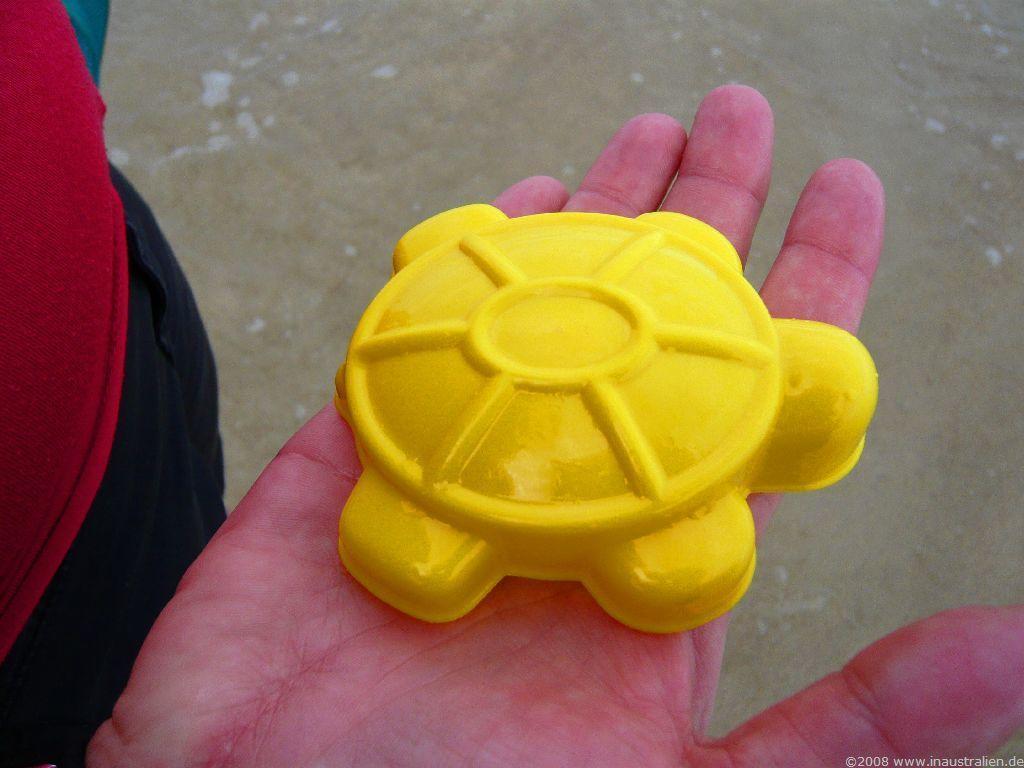Could you give a brief overview of what you see in this image? In this picture, we see the hand of the person holding a yellow color object. On the left side, we see a man wearing the red T-shirt and black pant. In the background, we see sand and water. 